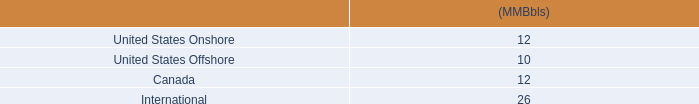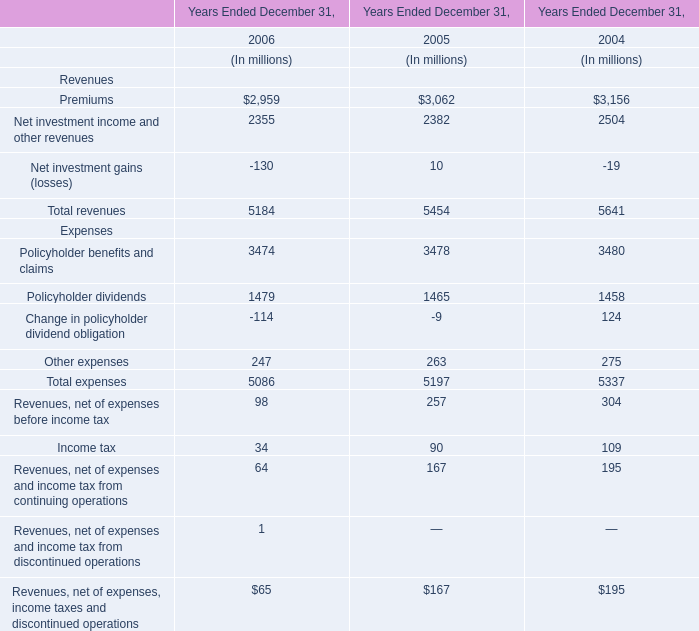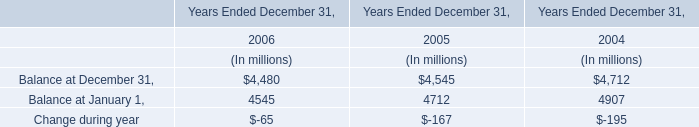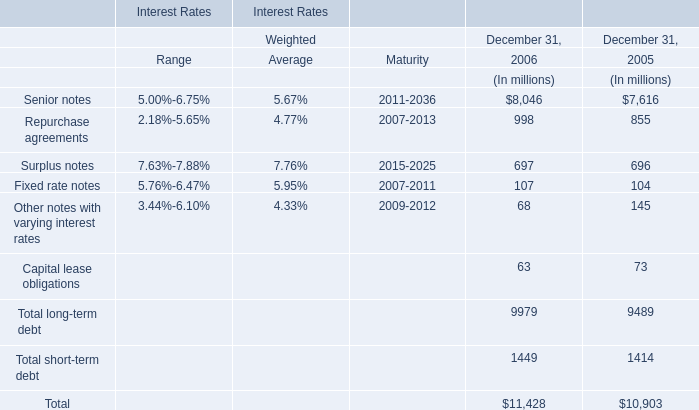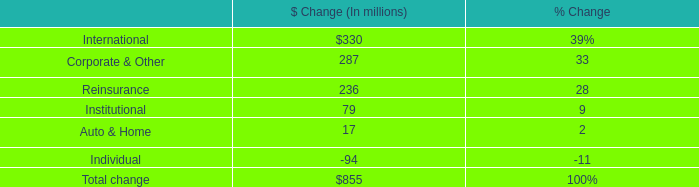What is the ratio of Balance at December 31, to the total in 2005? 
Computations: (4545 / (4545 + 4712))
Answer: 0.49098. 